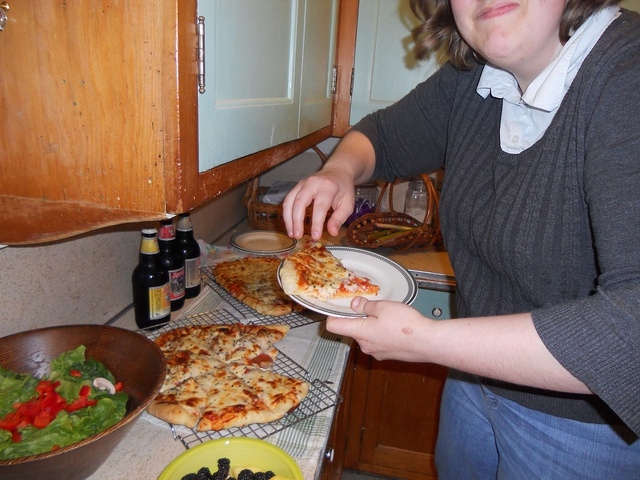Describe the objects in this image and their specific colors. I can see people in brown, gray, black, and lightpink tones, dining table in brown, darkgray, gray, and maroon tones, bowl in brown, darkgreen, maroon, and black tones, pizza in brown and tan tones, and pizza in brown, maroon, tan, and gray tones in this image. 